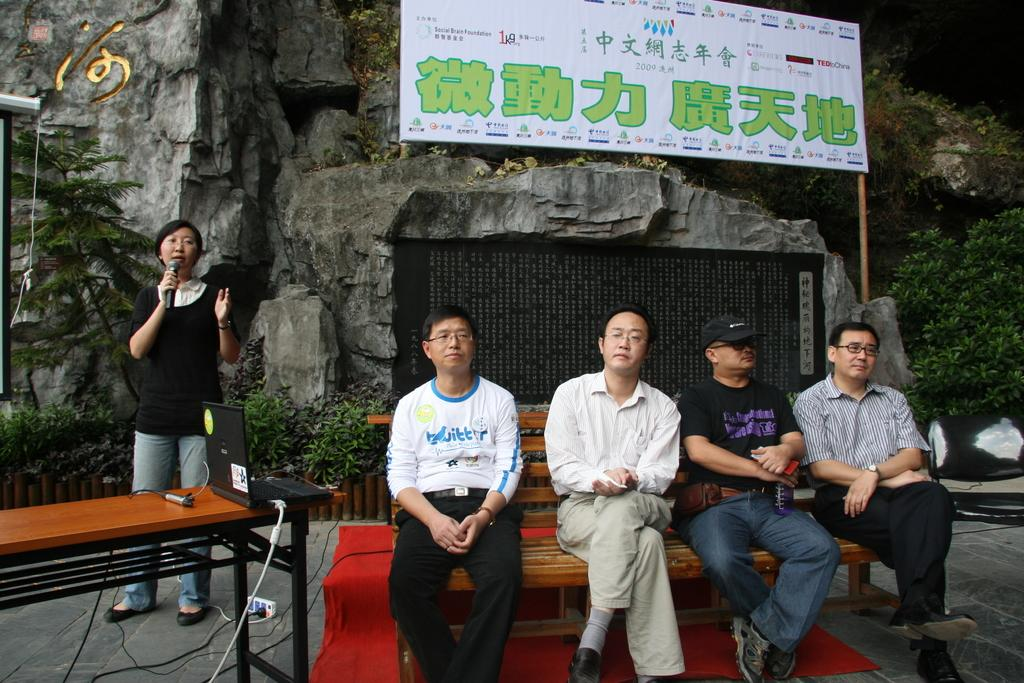What are the people in the image doing? There are people sitting on a bench in the image. What can be seen in the background of the image? There is a rock mountain in the background of the image. What is the woman in the image doing? A woman is speaking on a microphone in the image. How many buttons are on the shirt of the girl sitting on the bench? There is no girl mentioned in the facts, and no information about shirts or buttons is provided. 